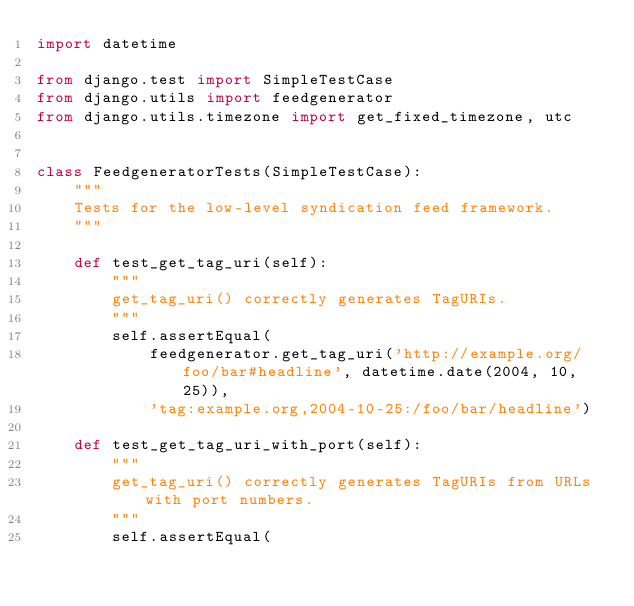Convert code to text. <code><loc_0><loc_0><loc_500><loc_500><_Python_>import datetime

from django.test import SimpleTestCase
from django.utils import feedgenerator
from django.utils.timezone import get_fixed_timezone, utc


class FeedgeneratorTests(SimpleTestCase):
    """
    Tests for the low-level syndication feed framework.
    """

    def test_get_tag_uri(self):
        """
        get_tag_uri() correctly generates TagURIs.
        """
        self.assertEqual(
            feedgenerator.get_tag_uri('http://example.org/foo/bar#headline', datetime.date(2004, 10, 25)),
            'tag:example.org,2004-10-25:/foo/bar/headline')

    def test_get_tag_uri_with_port(self):
        """
        get_tag_uri() correctly generates TagURIs from URLs with port numbers.
        """
        self.assertEqual(</code> 